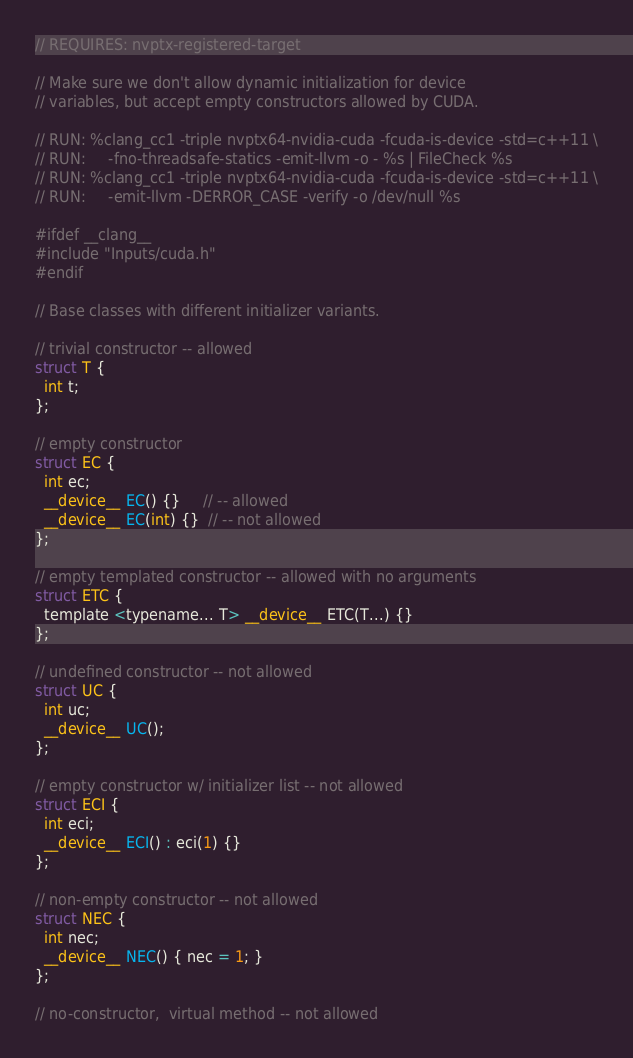Convert code to text. <code><loc_0><loc_0><loc_500><loc_500><_Cuda_>// REQUIRES: nvptx-registered-target

// Make sure we don't allow dynamic initialization for device
// variables, but accept empty constructors allowed by CUDA.

// RUN: %clang_cc1 -triple nvptx64-nvidia-cuda -fcuda-is-device -std=c++11 \
// RUN:     -fno-threadsafe-statics -emit-llvm -o - %s | FileCheck %s
// RUN: %clang_cc1 -triple nvptx64-nvidia-cuda -fcuda-is-device -std=c++11 \
// RUN:     -emit-llvm -DERROR_CASE -verify -o /dev/null %s

#ifdef __clang__
#include "Inputs/cuda.h"
#endif

// Base classes with different initializer variants.

// trivial constructor -- allowed
struct T {
  int t;
};

// empty constructor
struct EC {
  int ec;
  __device__ EC() {}     // -- allowed
  __device__ EC(int) {}  // -- not allowed
};

// empty templated constructor -- allowed with no arguments
struct ETC {
  template <typename... T> __device__ ETC(T...) {}
};

// undefined constructor -- not allowed
struct UC {
  int uc;
  __device__ UC();
};

// empty constructor w/ initializer list -- not allowed
struct ECI {
  int eci;
  __device__ ECI() : eci(1) {}
};

// non-empty constructor -- not allowed
struct NEC {
  int nec;
  __device__ NEC() { nec = 1; }
};

// no-constructor,  virtual method -- not allowed</code> 